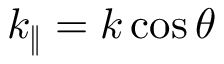<formula> <loc_0><loc_0><loc_500><loc_500>k _ { \| } = k \cos \theta</formula> 